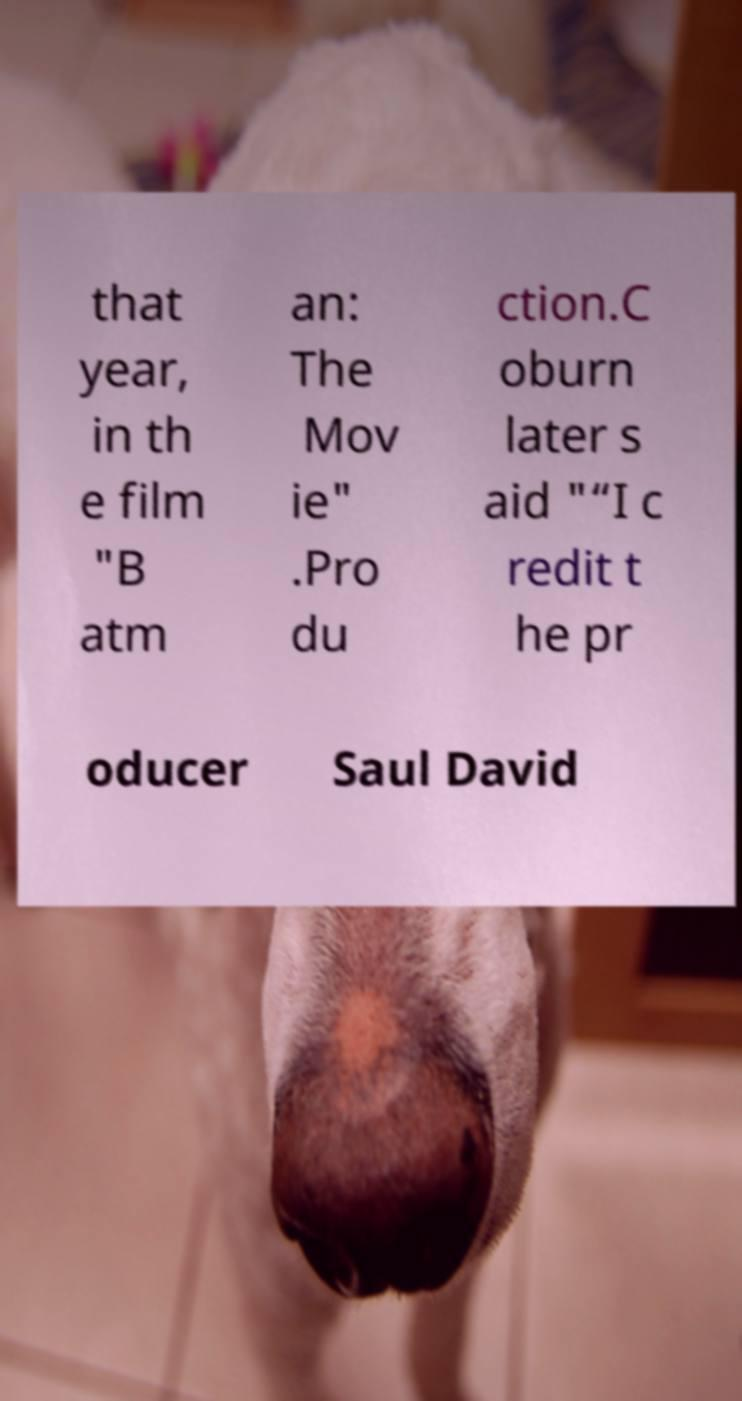Please identify and transcribe the text found in this image. that year, in th e film "B atm an: The Mov ie" .Pro du ction.C oburn later s aid "“I c redit t he pr oducer Saul David 